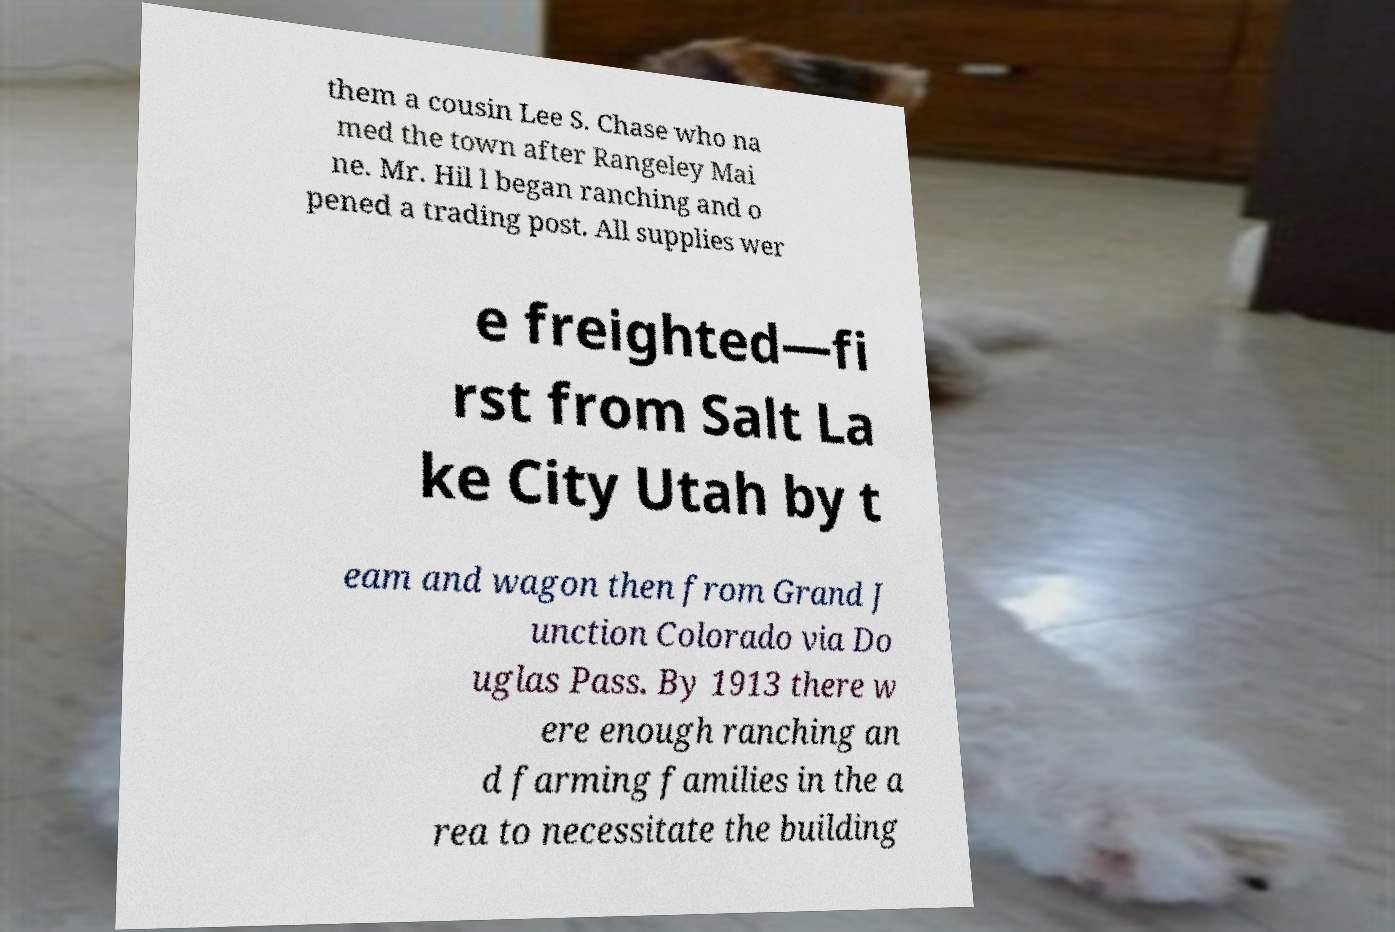Could you assist in decoding the text presented in this image and type it out clearly? them a cousin Lee S. Chase who na med the town after Rangeley Mai ne. Mr. Hil l began ranching and o pened a trading post. All supplies wer e freighted—fi rst from Salt La ke City Utah by t eam and wagon then from Grand J unction Colorado via Do uglas Pass. By 1913 there w ere enough ranching an d farming families in the a rea to necessitate the building 